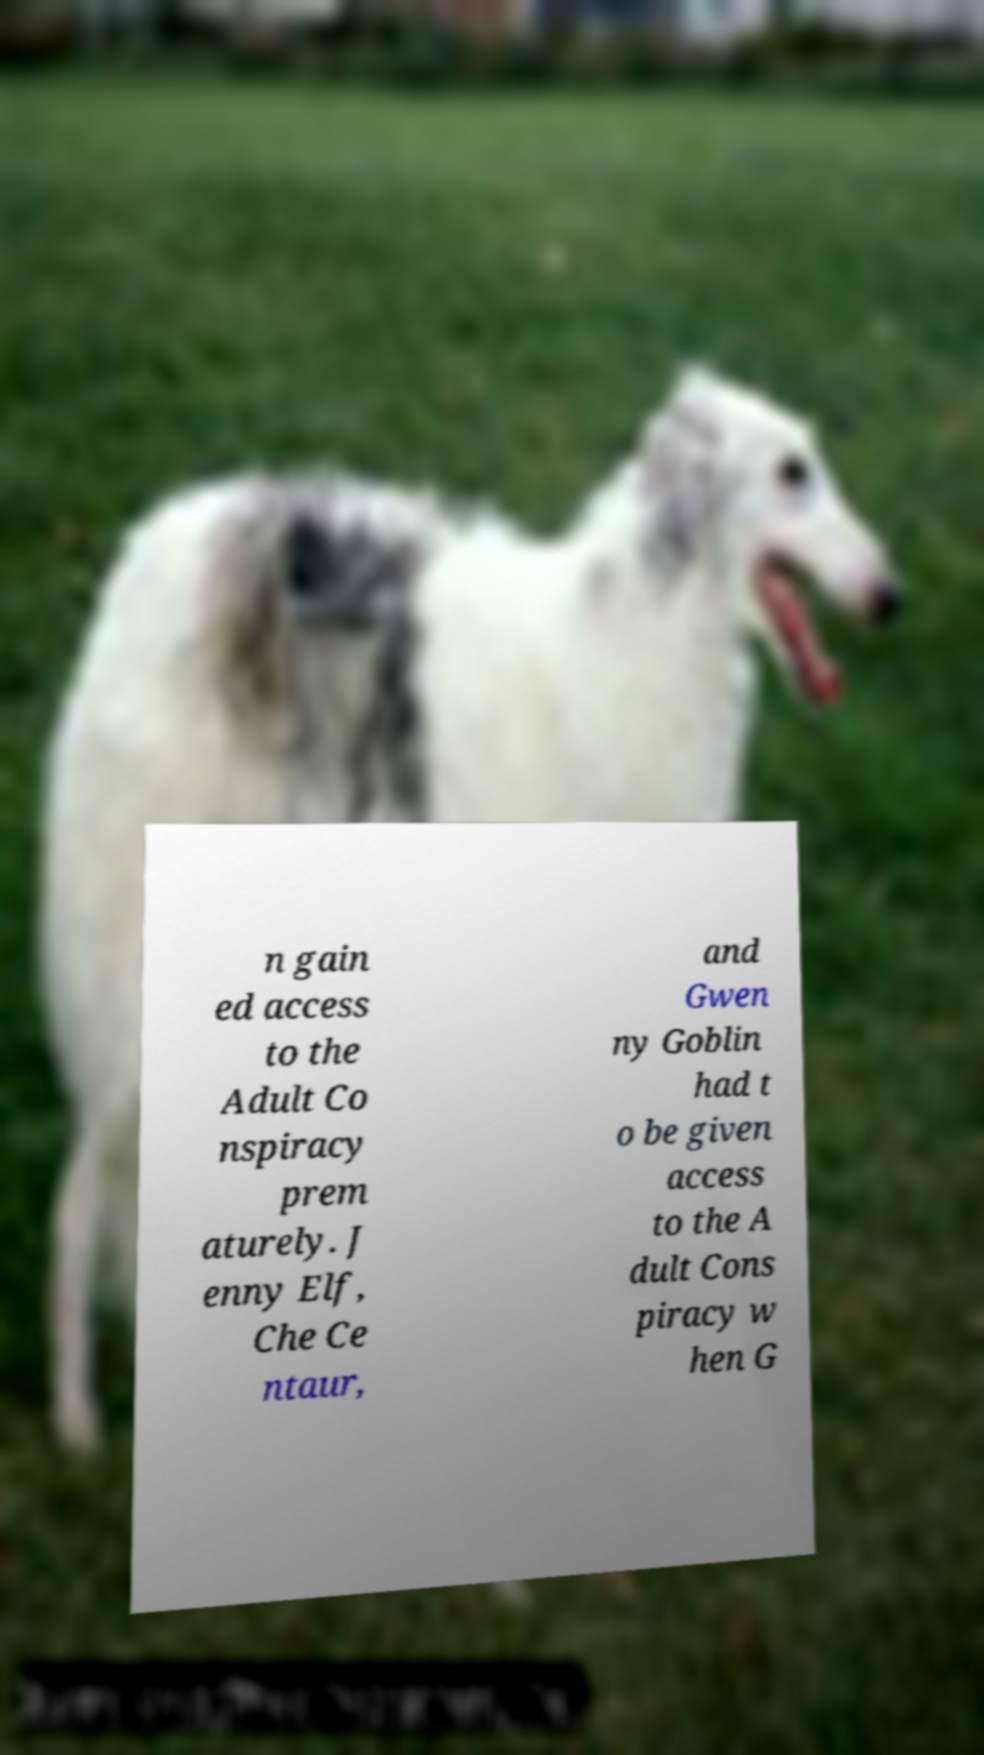Please read and relay the text visible in this image. What does it say? n gain ed access to the Adult Co nspiracy prem aturely. J enny Elf, Che Ce ntaur, and Gwen ny Goblin had t o be given access to the A dult Cons piracy w hen G 